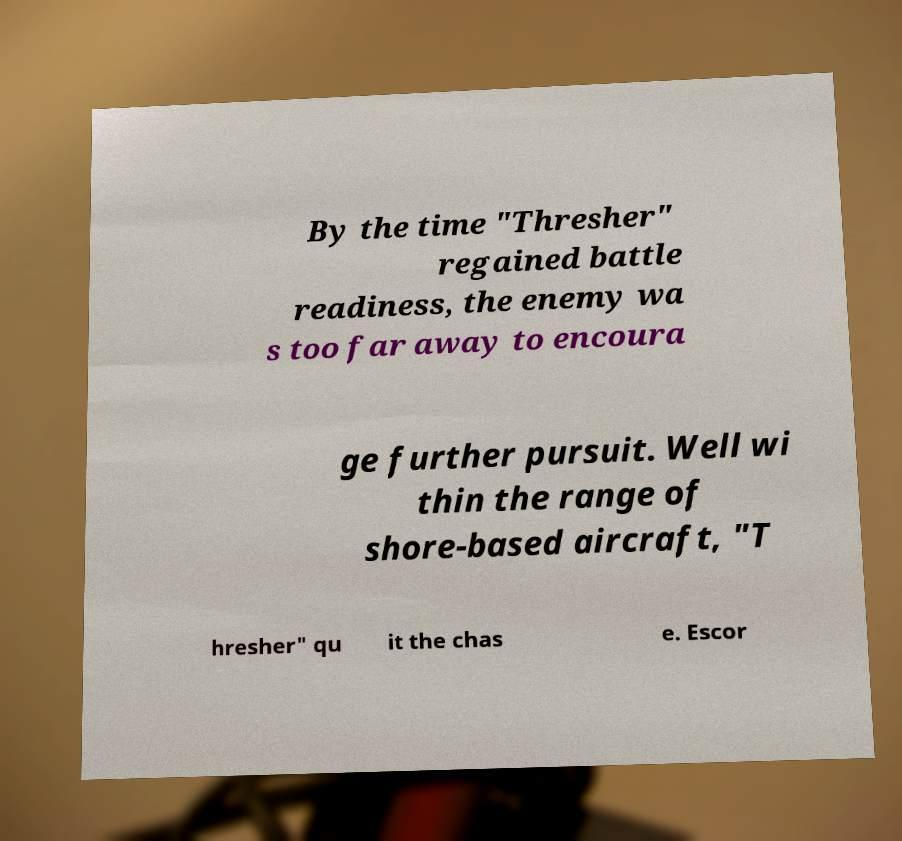Please identify and transcribe the text found in this image. By the time "Thresher" regained battle readiness, the enemy wa s too far away to encoura ge further pursuit. Well wi thin the range of shore-based aircraft, "T hresher" qu it the chas e. Escor 